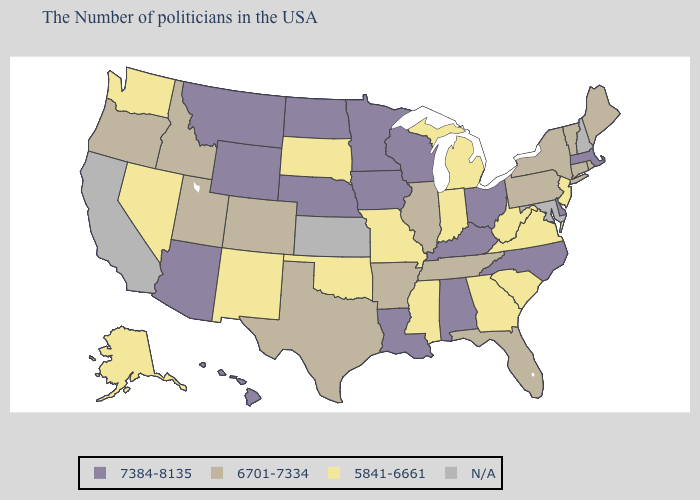What is the lowest value in the South?
Write a very short answer. 5841-6661. What is the highest value in the Northeast ?
Answer briefly. 7384-8135. What is the highest value in the USA?
Be succinct. 7384-8135. What is the lowest value in the USA?
Be succinct. 5841-6661. Name the states that have a value in the range N/A?
Give a very brief answer. New Hampshire, Maryland, Kansas, California. Among the states that border Missouri , which have the highest value?
Concise answer only. Kentucky, Iowa, Nebraska. Does Illinois have the lowest value in the MidWest?
Give a very brief answer. No. What is the value of Virginia?
Give a very brief answer. 5841-6661. Name the states that have a value in the range 6701-7334?
Be succinct. Maine, Rhode Island, Vermont, Connecticut, New York, Pennsylvania, Florida, Tennessee, Illinois, Arkansas, Texas, Colorado, Utah, Idaho, Oregon. What is the lowest value in the USA?
Give a very brief answer. 5841-6661. What is the value of Wyoming?
Keep it brief. 7384-8135. What is the value of Kansas?
Write a very short answer. N/A. What is the lowest value in the USA?
Answer briefly. 5841-6661. Is the legend a continuous bar?
Answer briefly. No. Among the states that border Tennessee , does Georgia have the lowest value?
Write a very short answer. Yes. 